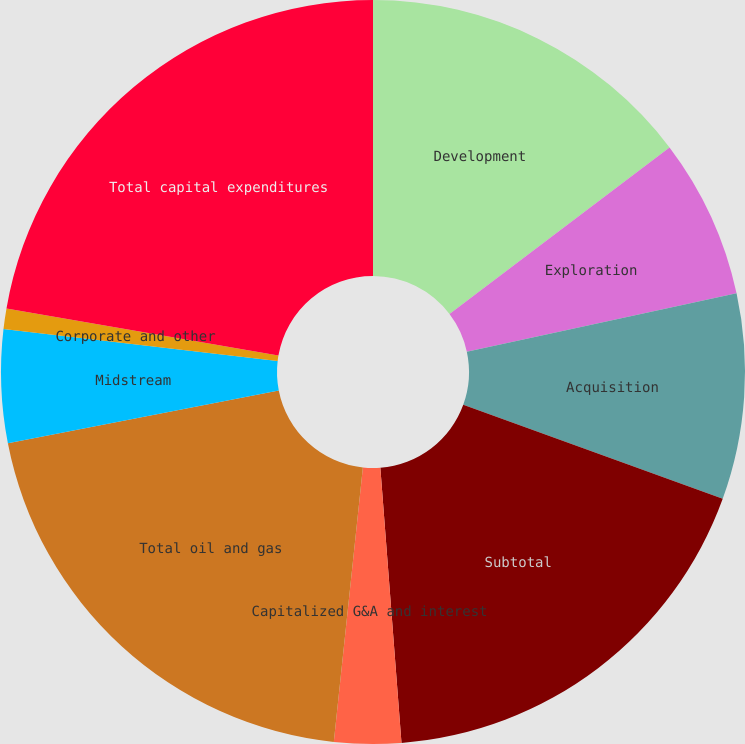Convert chart. <chart><loc_0><loc_0><loc_500><loc_500><pie_chart><fcel>Development<fcel>Exploration<fcel>Acquisition<fcel>Subtotal<fcel>Capitalized G&A and interest<fcel>Total oil and gas<fcel>Midstream<fcel>Corporate and other<fcel>Total capital expenditures<nl><fcel>14.68%<fcel>6.92%<fcel>8.93%<fcel>18.24%<fcel>2.9%<fcel>20.25%<fcel>4.91%<fcel>0.89%<fcel>22.26%<nl></chart> 